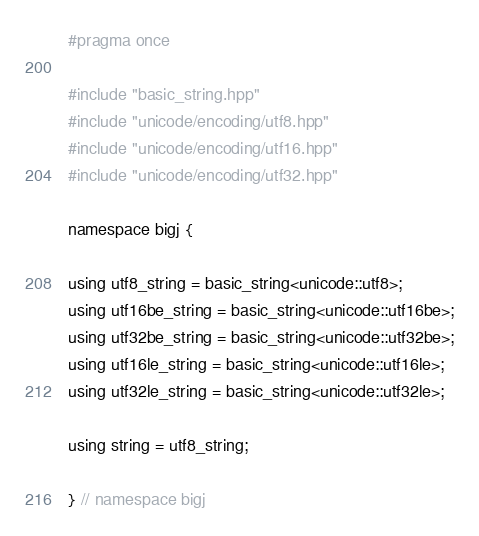Convert code to text. <code><loc_0><loc_0><loc_500><loc_500><_C++_>#pragma once

#include "basic_string.hpp"
#include "unicode/encoding/utf8.hpp"
#include "unicode/encoding/utf16.hpp"
#include "unicode/encoding/utf32.hpp"

namespace bigj {

using utf8_string = basic_string<unicode::utf8>;
using utf16be_string = basic_string<unicode::utf16be>;
using utf32be_string = basic_string<unicode::utf32be>;
using utf16le_string = basic_string<unicode::utf16le>;
using utf32le_string = basic_string<unicode::utf32le>;

using string = utf8_string;

} // namespace bigj
</code> 